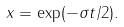<formula> <loc_0><loc_0><loc_500><loc_500>x = \exp ( - \sigma t / 2 ) .</formula> 